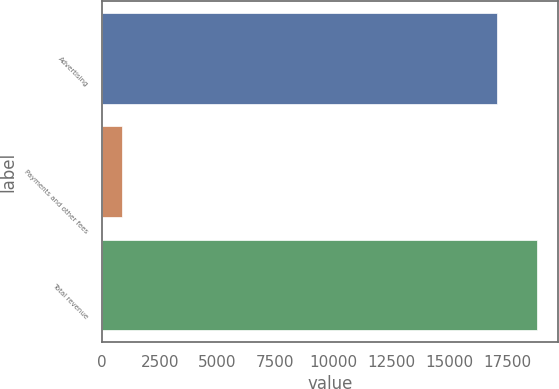Convert chart to OTSL. <chart><loc_0><loc_0><loc_500><loc_500><bar_chart><fcel>Advertising<fcel>Payments and other fees<fcel>Total revenue<nl><fcel>17079<fcel>849<fcel>18786.9<nl></chart> 